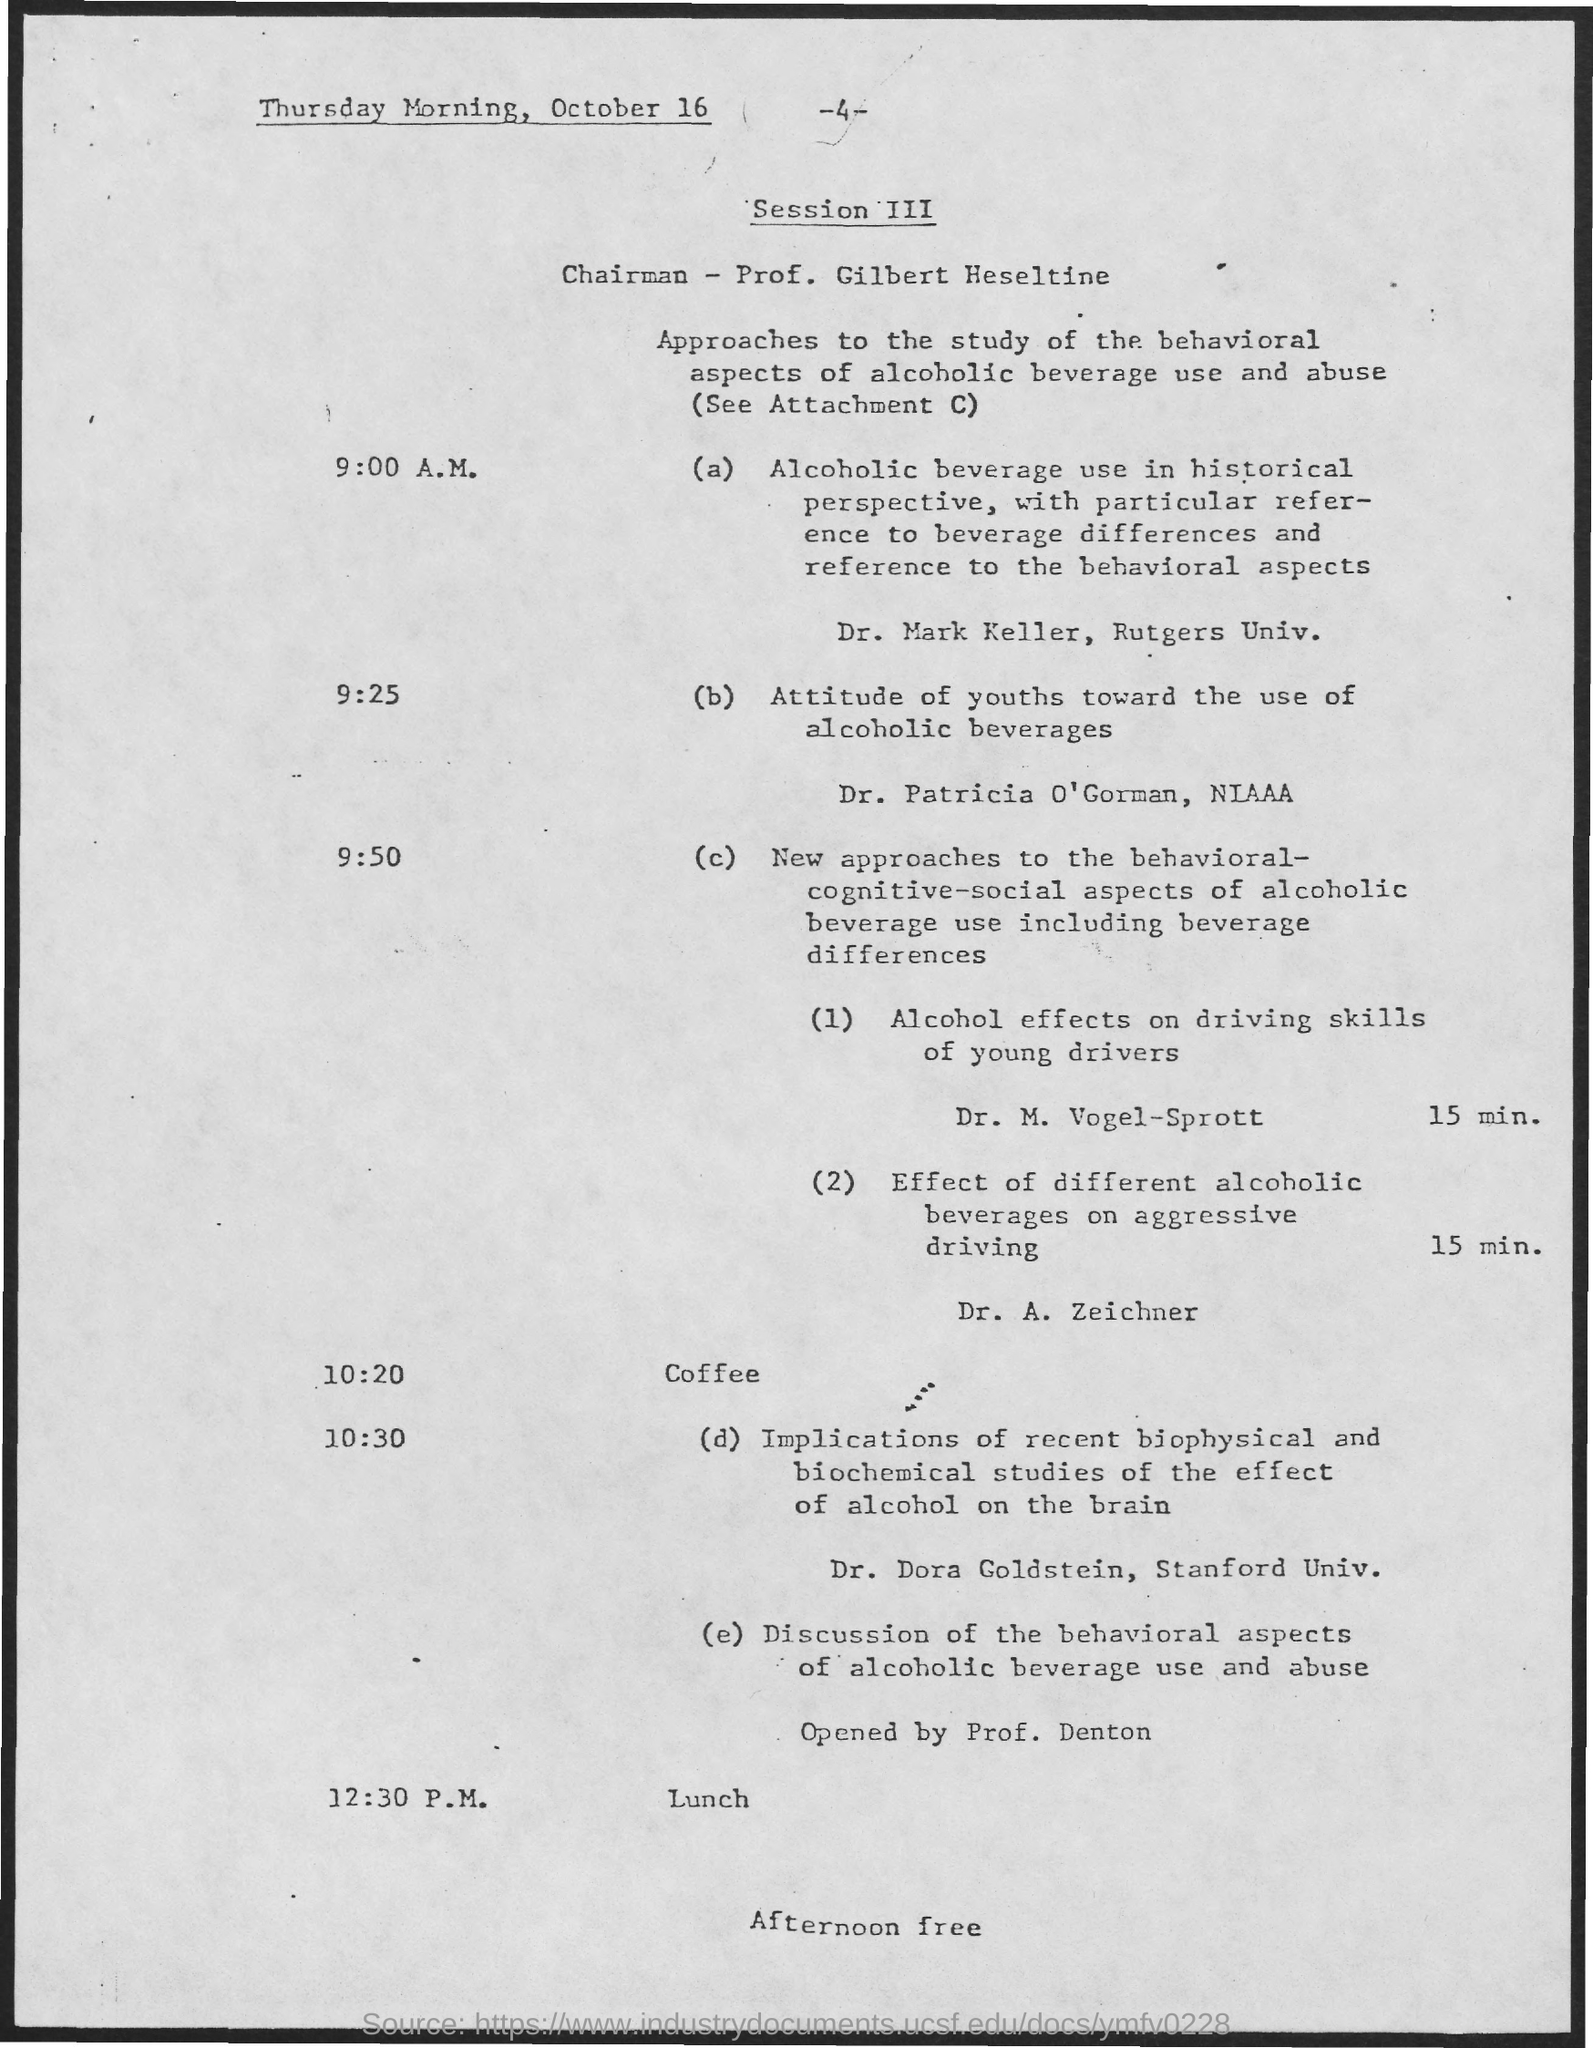Indicate a few pertinent items in this graphic. The schedule at 10:20 as mentioned on the given page is coffee. At 12:30 pm, as mentioned in the given page, lunch is scheduled. The chairman's name mentioned on the given page is Prof. Gilbert Heseltine. 